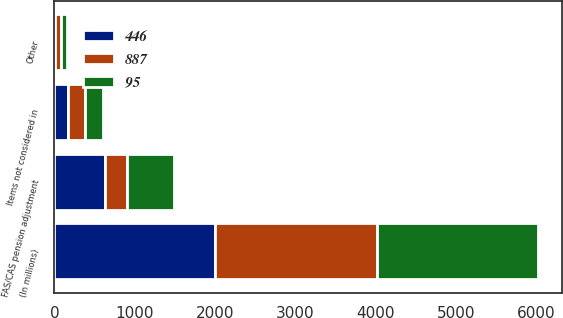Convert chart to OTSL. <chart><loc_0><loc_0><loc_500><loc_500><stacked_bar_chart><ecel><fcel>(In millions)<fcel>FAS/CAS pension adjustment<fcel>Items not considered in<fcel>Other<nl><fcel>887<fcel>2006<fcel>275<fcel>214<fcel>77<nl><fcel>446<fcel>2005<fcel>626<fcel>173<fcel>7<nl><fcel>95<fcel>2004<fcel>595<fcel>215<fcel>77<nl></chart> 